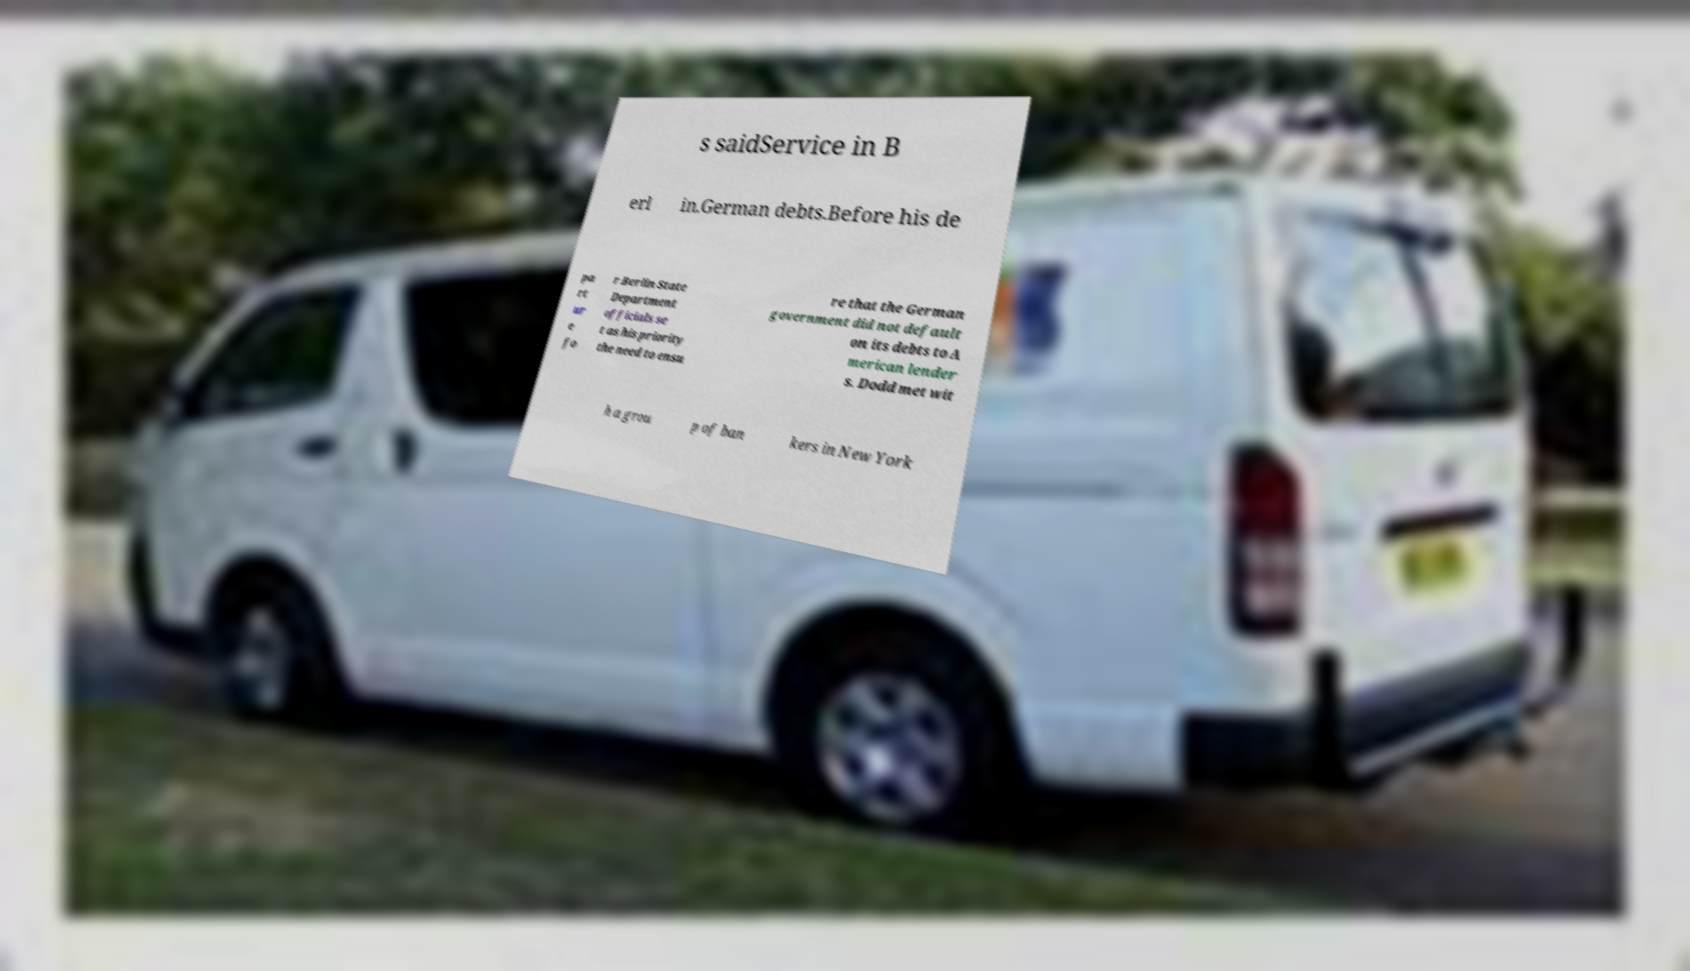I need the written content from this picture converted into text. Can you do that? s saidService in B erl in.German debts.Before his de pa rt ur e fo r Berlin State Department officials se t as his priority the need to ensu re that the German government did not default on its debts to A merican lender s. Dodd met wit h a grou p of ban kers in New York 